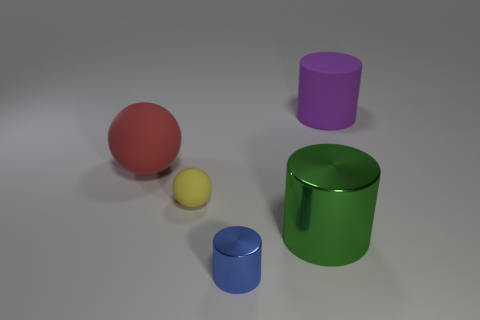Add 4 big purple matte objects. How many objects exist? 9 Subtract all cylinders. How many objects are left? 2 Subtract all large green matte blocks. Subtract all small yellow spheres. How many objects are left? 4 Add 3 small shiny things. How many small shiny things are left? 4 Add 4 large green metallic objects. How many large green metallic objects exist? 5 Subtract 1 yellow balls. How many objects are left? 4 